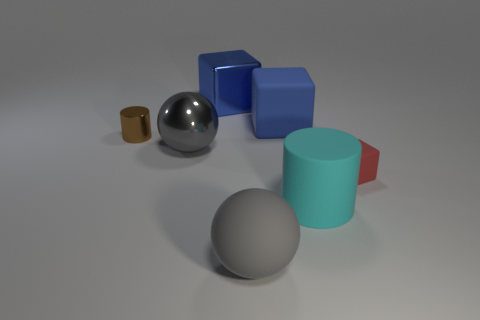Add 1 big gray matte cubes. How many objects exist? 8 Subtract all cylinders. How many objects are left? 5 Add 7 red rubber blocks. How many red rubber blocks are left? 8 Add 4 rubber cubes. How many rubber cubes exist? 6 Subtract 1 red cubes. How many objects are left? 6 Subtract all blue matte things. Subtract all big blue cubes. How many objects are left? 4 